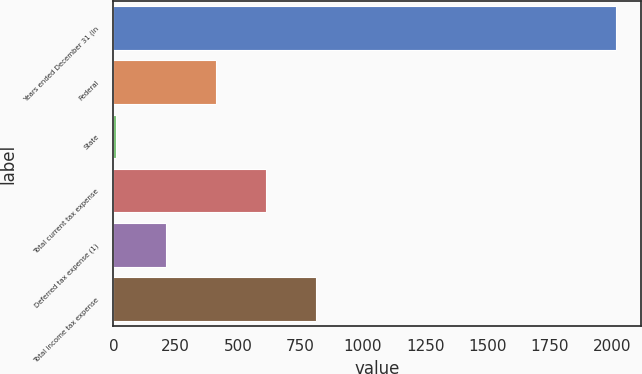Convert chart. <chart><loc_0><loc_0><loc_500><loc_500><bar_chart><fcel>Years ended December 31 (in<fcel>Federal<fcel>State<fcel>Total current tax expense<fcel>Deferred tax expense (1)<fcel>Total income tax expense<nl><fcel>2013<fcel>410.2<fcel>9.5<fcel>610.55<fcel>209.85<fcel>810.9<nl></chart> 